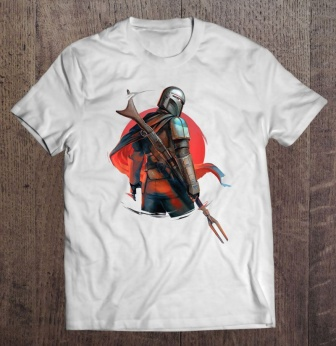What do you think is going on in this snapshot? The image showcases a white t-shirt featuring a detailed graphic design of a medieval knight, portrayed against a bold red circle backdrop. The knight, clothed in a meticulously designed armor painted in blue and silver, stands wielding a sword and a spear, exuding an aura of strength and chivalry. This portrayal not just captures the eye but also invites interpretations of valor and heroism reminiscent of medieval folklore, possibly drawing inspiration from historical or fantasy narratives. 